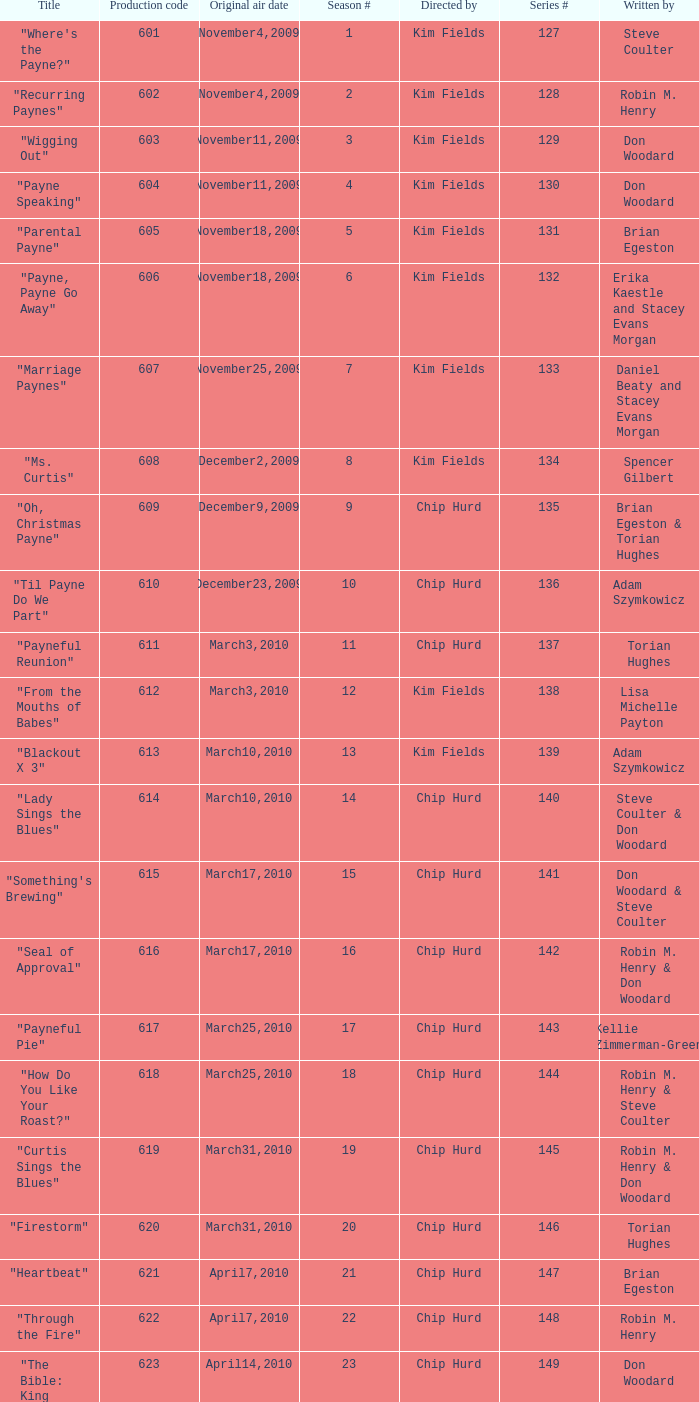What is the title of the episode with the production code 624? "Matured Investment". 